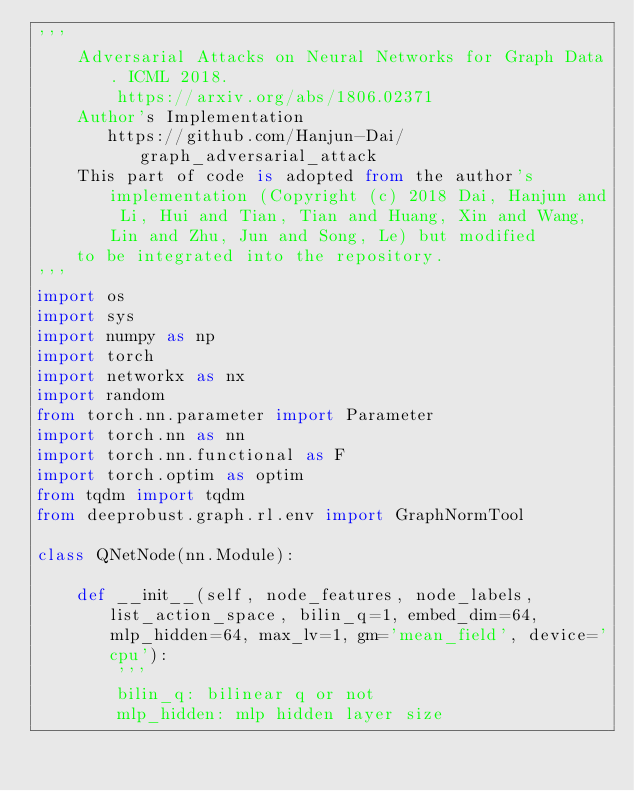<code> <loc_0><loc_0><loc_500><loc_500><_Python_>'''
    Adversarial Attacks on Neural Networks for Graph Data. ICML 2018.
        https://arxiv.org/abs/1806.02371
    Author's Implementation
       https://github.com/Hanjun-Dai/graph_adversarial_attack
    This part of code is adopted from the author's implementation (Copyright (c) 2018 Dai, Hanjun and Li, Hui and Tian, Tian and Huang, Xin and Wang, Lin and Zhu, Jun and Song, Le) but modified
    to be integrated into the repository.
'''
import os
import sys
import numpy as np
import torch
import networkx as nx
import random
from torch.nn.parameter import Parameter
import torch.nn as nn
import torch.nn.functional as F
import torch.optim as optim
from tqdm import tqdm
from deeprobust.graph.rl.env import GraphNormTool

class QNetNode(nn.Module):

    def __init__(self, node_features, node_labels, list_action_space, bilin_q=1, embed_dim=64, mlp_hidden=64, max_lv=1, gm='mean_field', device='cpu'):
        '''
        bilin_q: bilinear q or not
        mlp_hidden: mlp hidden layer size</code> 